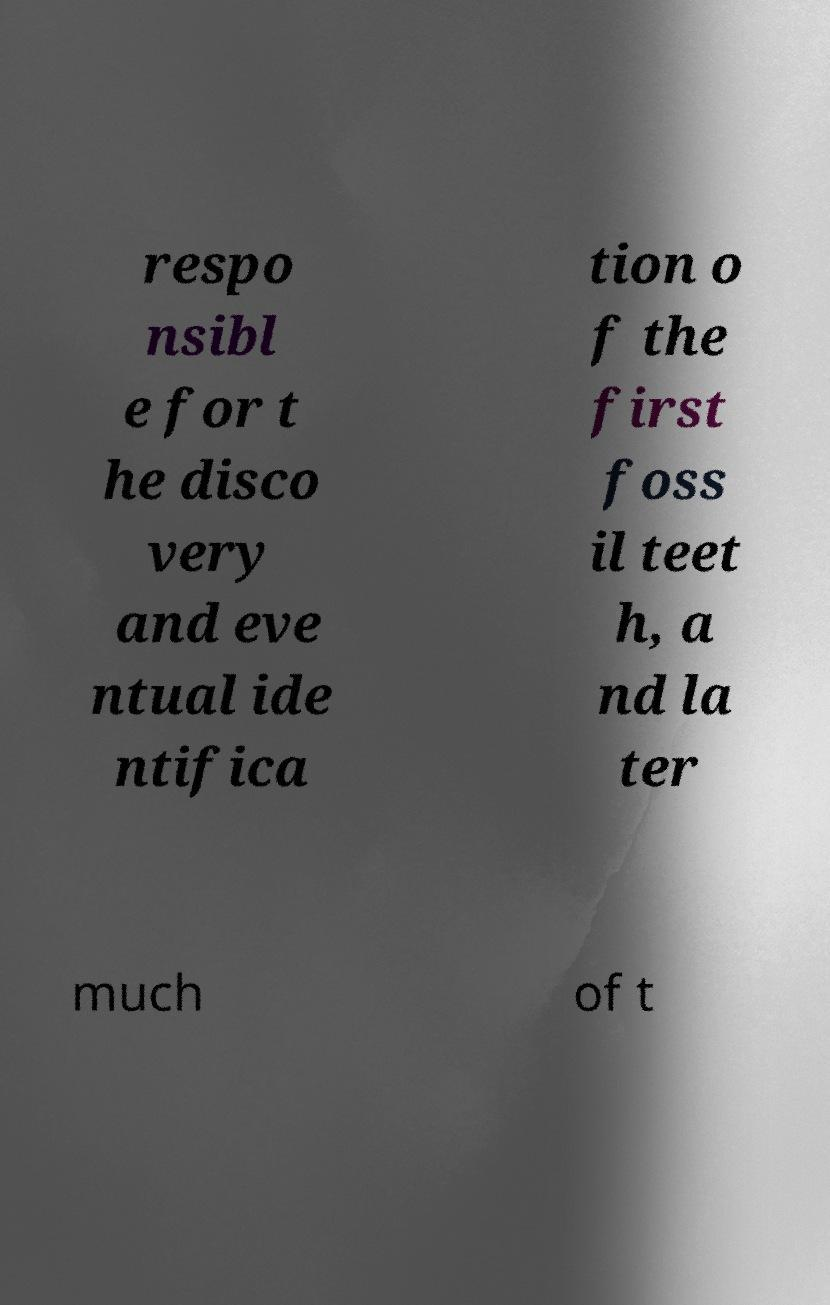There's text embedded in this image that I need extracted. Can you transcribe it verbatim? respo nsibl e for t he disco very and eve ntual ide ntifica tion o f the first foss il teet h, a nd la ter much of t 